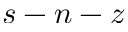<formula> <loc_0><loc_0><loc_500><loc_500>s - n - z</formula> 